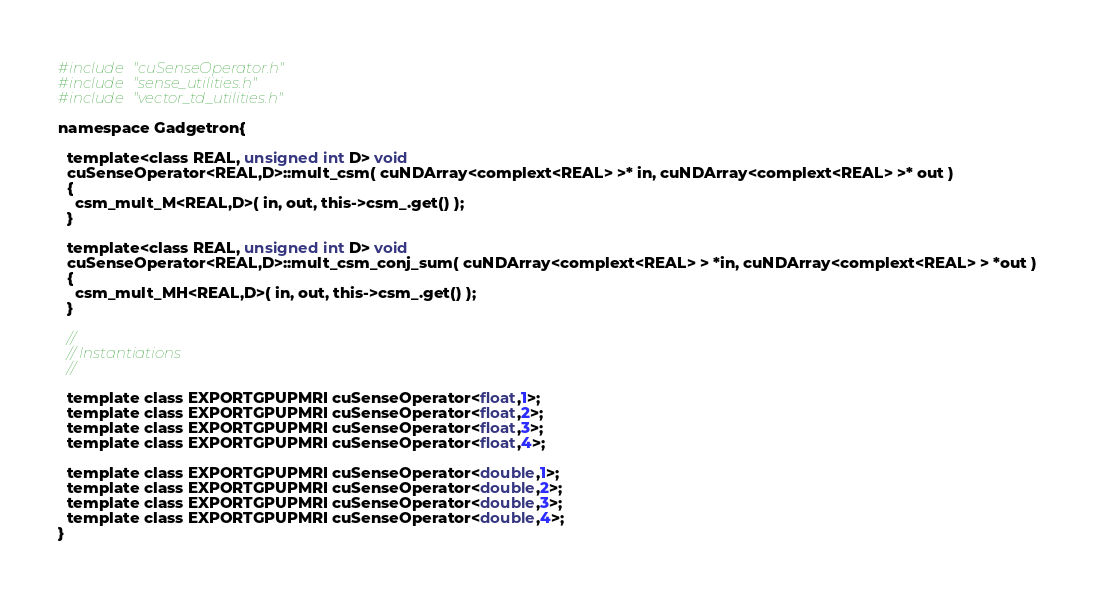Convert code to text. <code><loc_0><loc_0><loc_500><loc_500><_Cuda_>#include "cuSenseOperator.h"
#include "sense_utilities.h"
#include "vector_td_utilities.h"

namespace Gadgetron{

  template<class REAL, unsigned int D> void
  cuSenseOperator<REAL,D>::mult_csm( cuNDArray<complext<REAL> >* in, cuNDArray<complext<REAL> >* out )
  {  
    csm_mult_M<REAL,D>( in, out, this->csm_.get() );
  }
  
  template<class REAL, unsigned int D> void
  cuSenseOperator<REAL,D>::mult_csm_conj_sum( cuNDArray<complext<REAL> > *in, cuNDArray<complext<REAL> > *out )
  {
    csm_mult_MH<REAL,D>( in, out, this->csm_.get() );
  }
  
  //
  // Instantiations
  //
  
  template class EXPORTGPUPMRI cuSenseOperator<float,1>;
  template class EXPORTGPUPMRI cuSenseOperator<float,2>;
  template class EXPORTGPUPMRI cuSenseOperator<float,3>;
  template class EXPORTGPUPMRI cuSenseOperator<float,4>;

  template class EXPORTGPUPMRI cuSenseOperator<double,1>;
  template class EXPORTGPUPMRI cuSenseOperator<double,2>;
  template class EXPORTGPUPMRI cuSenseOperator<double,3>;
  template class EXPORTGPUPMRI cuSenseOperator<double,4>;
}
</code> 